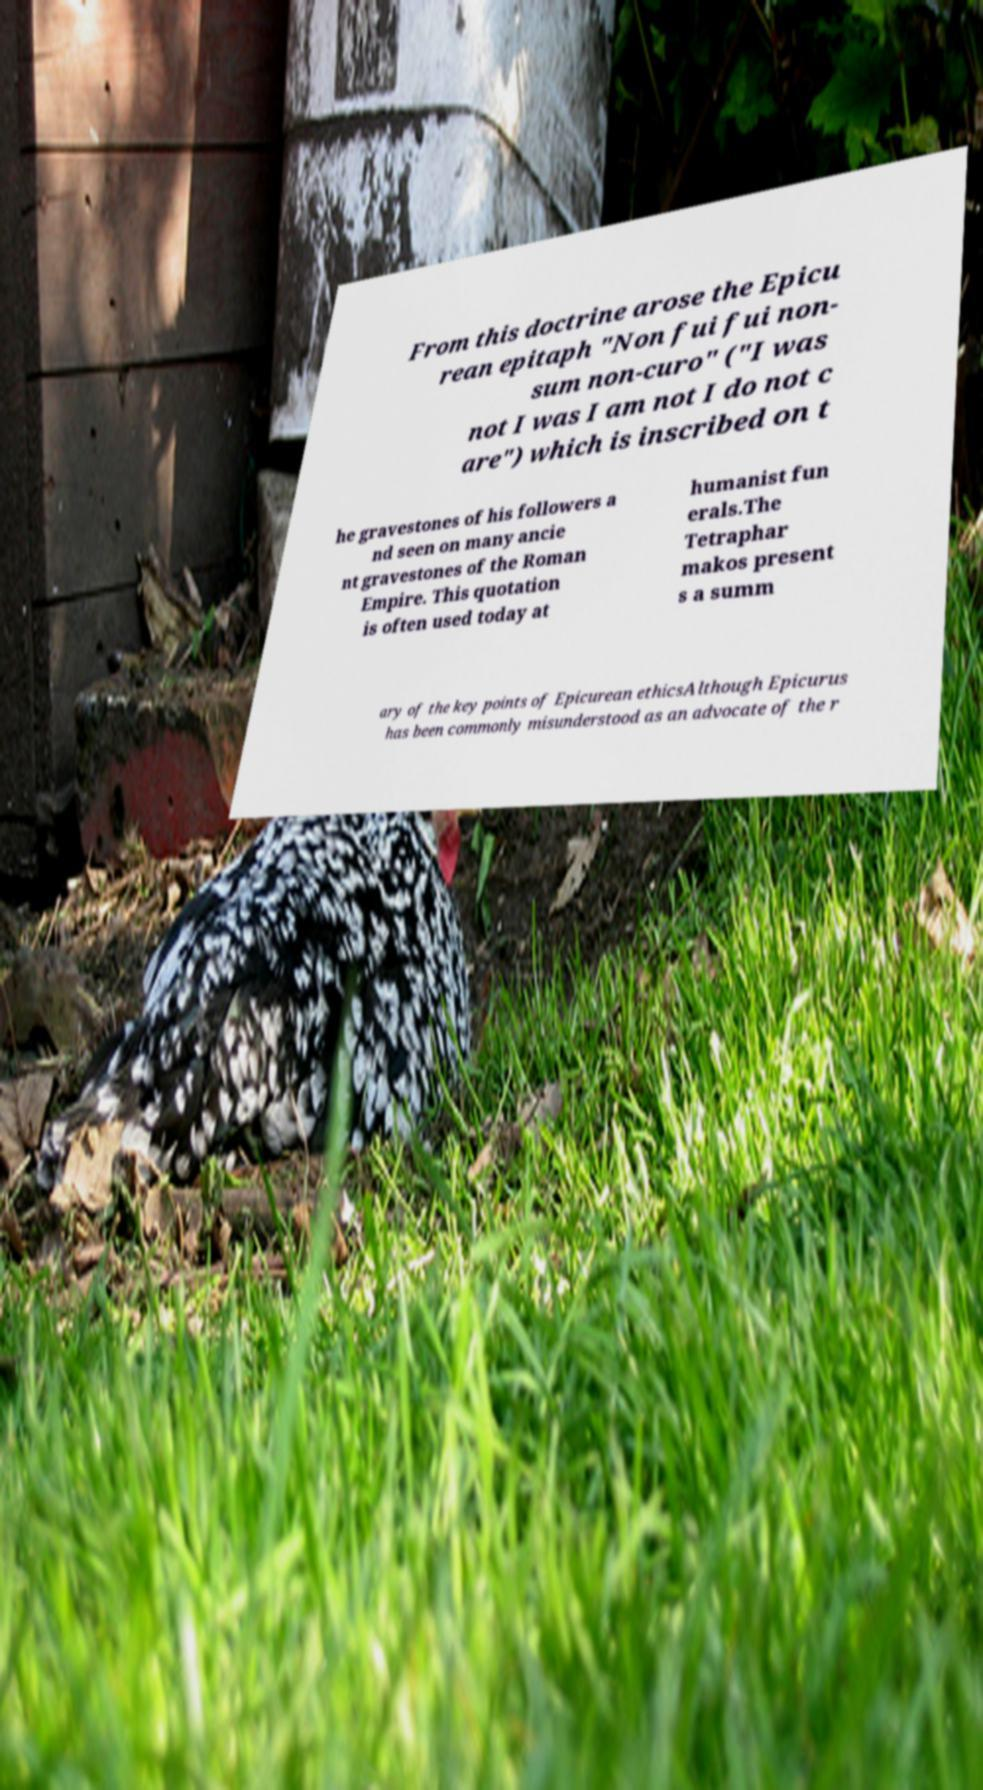Can you read and provide the text displayed in the image?This photo seems to have some interesting text. Can you extract and type it out for me? From this doctrine arose the Epicu rean epitaph "Non fui fui non- sum non-curo" ("I was not I was I am not I do not c are") which is inscribed on t he gravestones of his followers a nd seen on many ancie nt gravestones of the Roman Empire. This quotation is often used today at humanist fun erals.The Tetraphar makos present s a summ ary of the key points of Epicurean ethicsAlthough Epicurus has been commonly misunderstood as an advocate of the r 